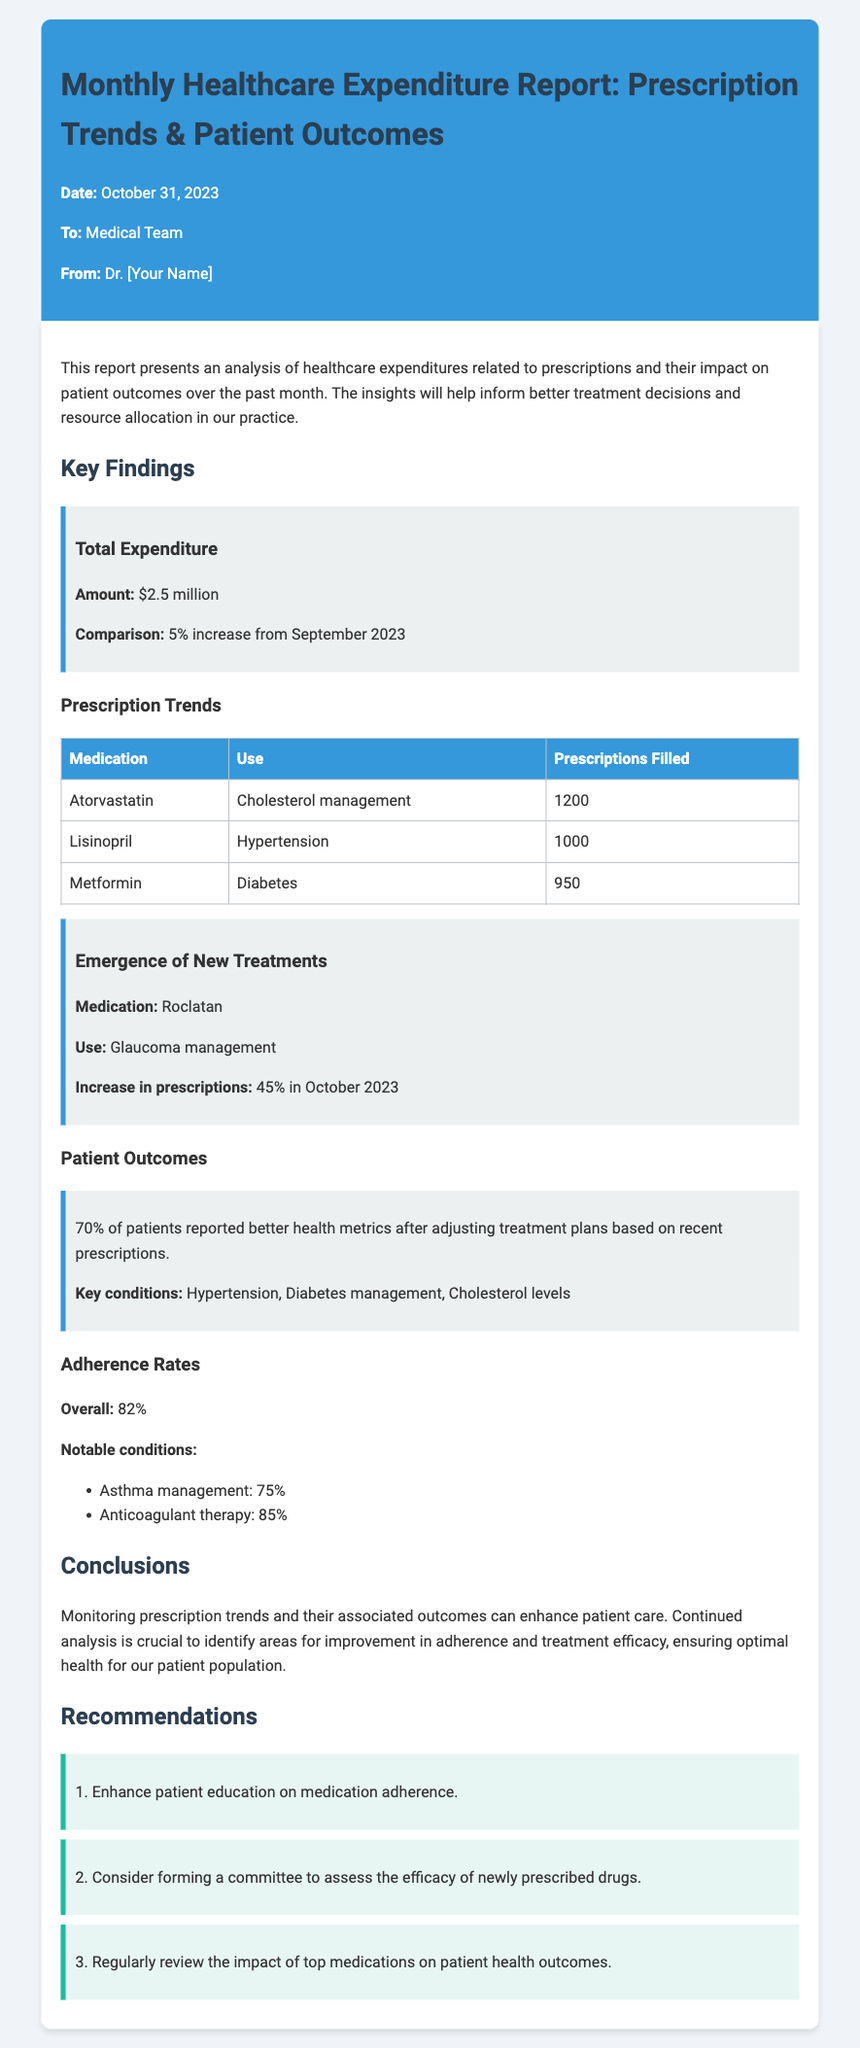what is the total expenditure for October 2023? The total expenditure mentioned in the document is $2.5 million.
Answer: $2.5 million how much did the expenditures increase from September 2023? The document states there is a 5% increase in expenditures compared to September 2023.
Answer: 5% which medication had the highest number of prescriptions filled? According to the table, Atorvastatin had the highest number of prescriptions filled at 1200.
Answer: Atorvastatin what percentage of patients reported better health metrics? The document indicates that 70% of patients reported better health metrics after adjusting treatment plans.
Answer: 70% what is the overall adherence rate mentioned in the report? The adherence rate stated in the report is 82%.
Answer: 82% which new medication had a 45% increase in prescriptions? The memo mentions Roclatan as the new medication with a 45% increase in prescriptions.
Answer: Roclatan what recommendation is made to enhance patient education? The document recommends enhancing patient education on medication adherence.
Answer: Enhance patient education on medication adherence which condition had the lowest adherence rate reported? The document states that asthma management had the lowest adherence rate at 75%.
Answer: Asthma management what are the key conditions linked to the 70% improved health metrics? The key conditions mentioned are hypertension, diabetes management, and cholesterol levels.
Answer: Hypertension, Diabetes management, Cholesterol levels 